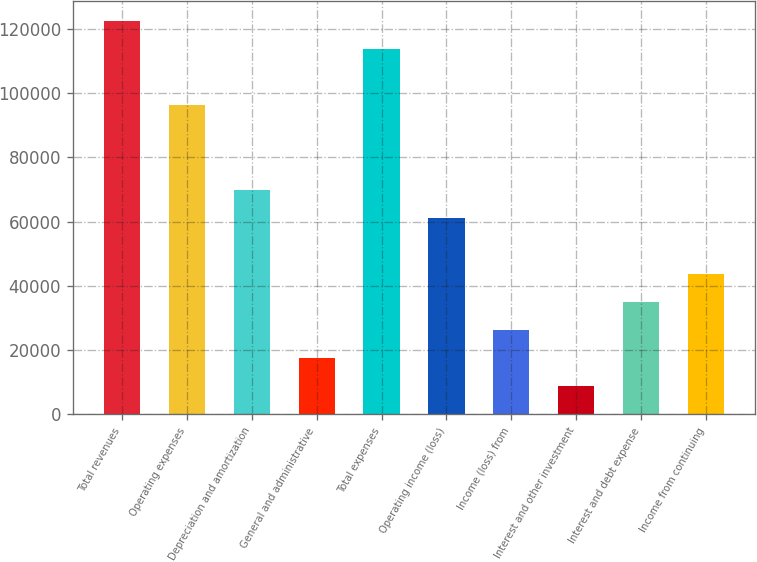<chart> <loc_0><loc_0><loc_500><loc_500><bar_chart><fcel>Total revenues<fcel>Operating expenses<fcel>Depreciation and amortization<fcel>General and administrative<fcel>Total expenses<fcel>Operating income (loss)<fcel>Income (loss) from<fcel>Interest and other investment<fcel>Interest and debt expense<fcel>Income from continuing<nl><fcel>122397<fcel>96170.2<fcel>69943.6<fcel>17490.3<fcel>113655<fcel>61201.4<fcel>26232.5<fcel>8748.11<fcel>34974.7<fcel>43716.9<nl></chart> 